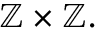Convert formula to latex. <formula><loc_0><loc_0><loc_500><loc_500>\mathbb { Z } \times \mathbb { Z } .</formula> 